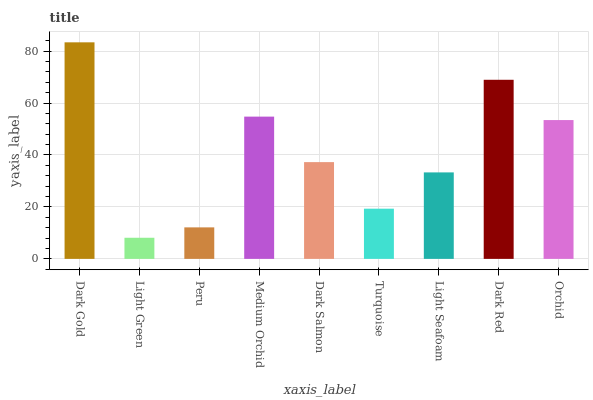Is Light Green the minimum?
Answer yes or no. Yes. Is Dark Gold the maximum?
Answer yes or no. Yes. Is Peru the minimum?
Answer yes or no. No. Is Peru the maximum?
Answer yes or no. No. Is Peru greater than Light Green?
Answer yes or no. Yes. Is Light Green less than Peru?
Answer yes or no. Yes. Is Light Green greater than Peru?
Answer yes or no. No. Is Peru less than Light Green?
Answer yes or no. No. Is Dark Salmon the high median?
Answer yes or no. Yes. Is Dark Salmon the low median?
Answer yes or no. Yes. Is Light Seafoam the high median?
Answer yes or no. No. Is Light Green the low median?
Answer yes or no. No. 